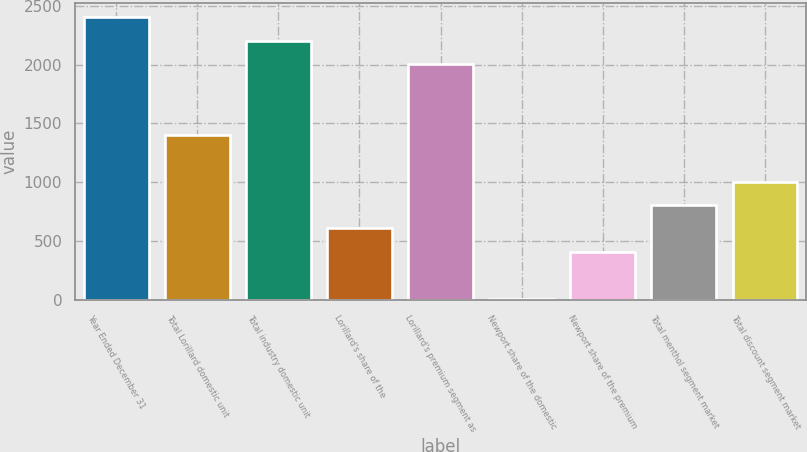Convert chart. <chart><loc_0><loc_0><loc_500><loc_500><bar_chart><fcel>Year Ended December 31<fcel>Total Lorillard domestic unit<fcel>Total industry domestic unit<fcel>Lorillard's share of the<fcel>Lorillard's premium segment as<fcel>Newport share of the domestic<fcel>Newport share of the premium<fcel>Total menthol segment market<fcel>Total discount segment market<nl><fcel>2403.22<fcel>1405.17<fcel>2203.61<fcel>606.73<fcel>2004<fcel>7.9<fcel>407.12<fcel>806.34<fcel>1005.95<nl></chart> 